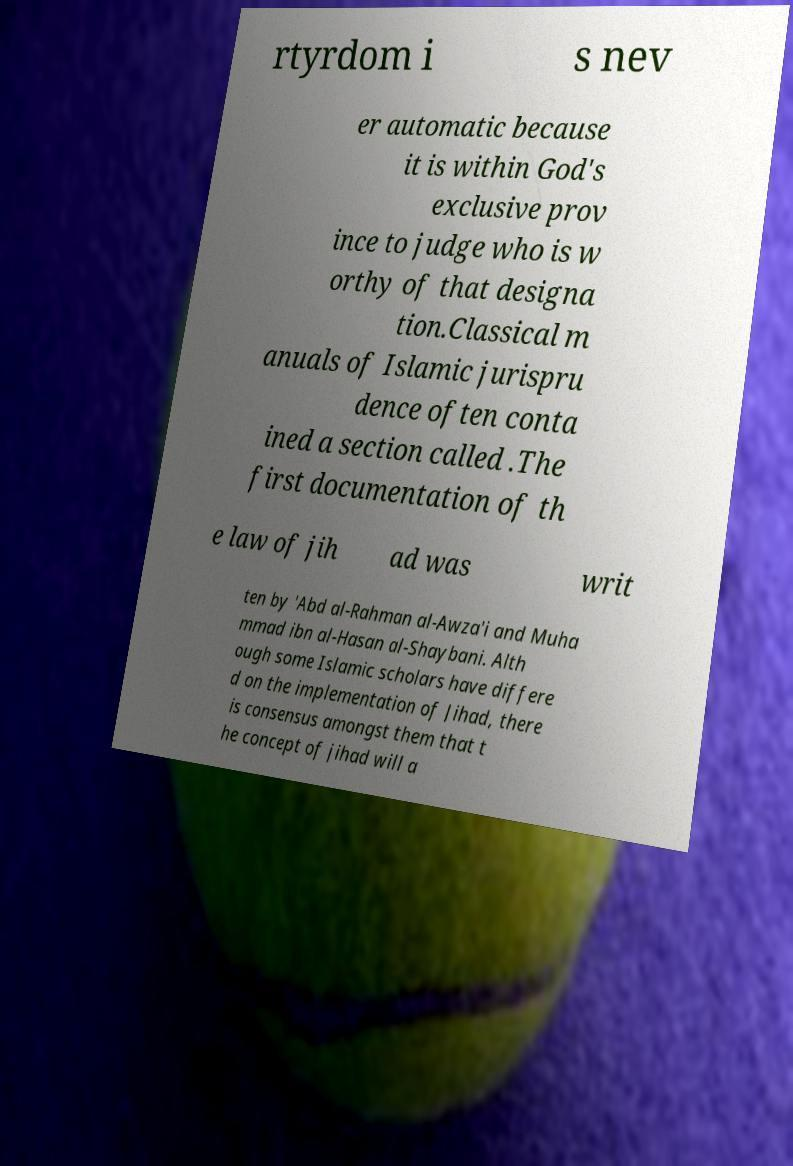For documentation purposes, I need the text within this image transcribed. Could you provide that? rtyrdom i s nev er automatic because it is within God's exclusive prov ince to judge who is w orthy of that designa tion.Classical m anuals of Islamic jurispru dence often conta ined a section called .The first documentation of th e law of jih ad was writ ten by 'Abd al-Rahman al-Awza'i and Muha mmad ibn al-Hasan al-Shaybani. Alth ough some Islamic scholars have differe d on the implementation of Jihad, there is consensus amongst them that t he concept of jihad will a 